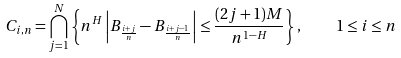<formula> <loc_0><loc_0><loc_500><loc_500>C _ { i , n } = \bigcap _ { j = 1 } ^ { N } \left \{ n ^ { H } \left | B _ { \frac { i + j } { n } } - B _ { \frac { i + j - 1 } { n } } \right | \leq \frac { ( 2 j + 1 ) M } { n ^ { 1 - H } } \right \} , \quad 1 \leq i \leq n</formula> 